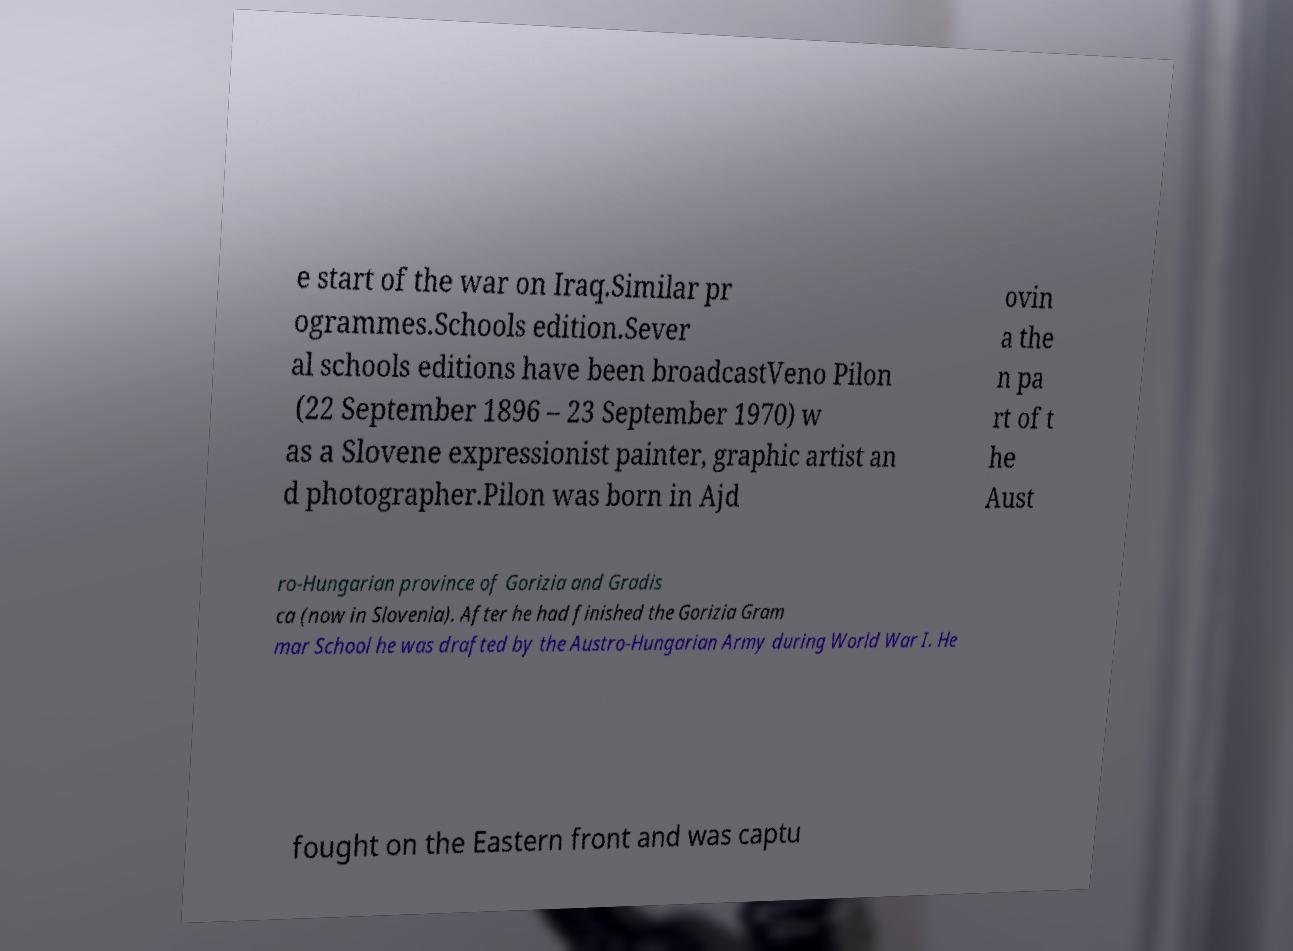Please identify and transcribe the text found in this image. e start of the war on Iraq.Similar pr ogrammes.Schools edition.Sever al schools editions have been broadcastVeno Pilon (22 September 1896 – 23 September 1970) w as a Slovene expressionist painter, graphic artist an d photographer.Pilon was born in Ajd ovin a the n pa rt of t he Aust ro-Hungarian province of Gorizia and Gradis ca (now in Slovenia). After he had finished the Gorizia Gram mar School he was drafted by the Austro-Hungarian Army during World War I. He fought on the Eastern front and was captu 